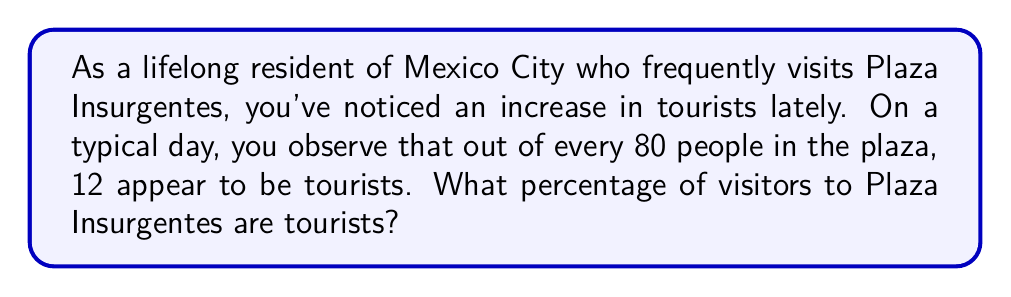Can you solve this math problem? To solve this problem, we need to calculate the percentage of tourists among the total number of visitors. Let's break it down step by step:

1. Identify the given information:
   - Total number of people observed: 80
   - Number of tourists: 12

2. Set up the percentage formula:
   $$ \text{Percentage} = \frac{\text{Part}}{\text{Whole}} \times 100\% $$

3. Plug in the values:
   $$ \text{Percentage of tourists} = \frac{12}{80} \times 100\% $$

4. Simplify the fraction:
   $$ \frac{12}{80} = \frac{3}{20} $$

5. Perform the multiplication:
   $$ \frac{3}{20} \times 100\% = 15\% $$

Therefore, the percentage of tourists visiting Plaza Insurgentes is 15%.
Answer: 15% 